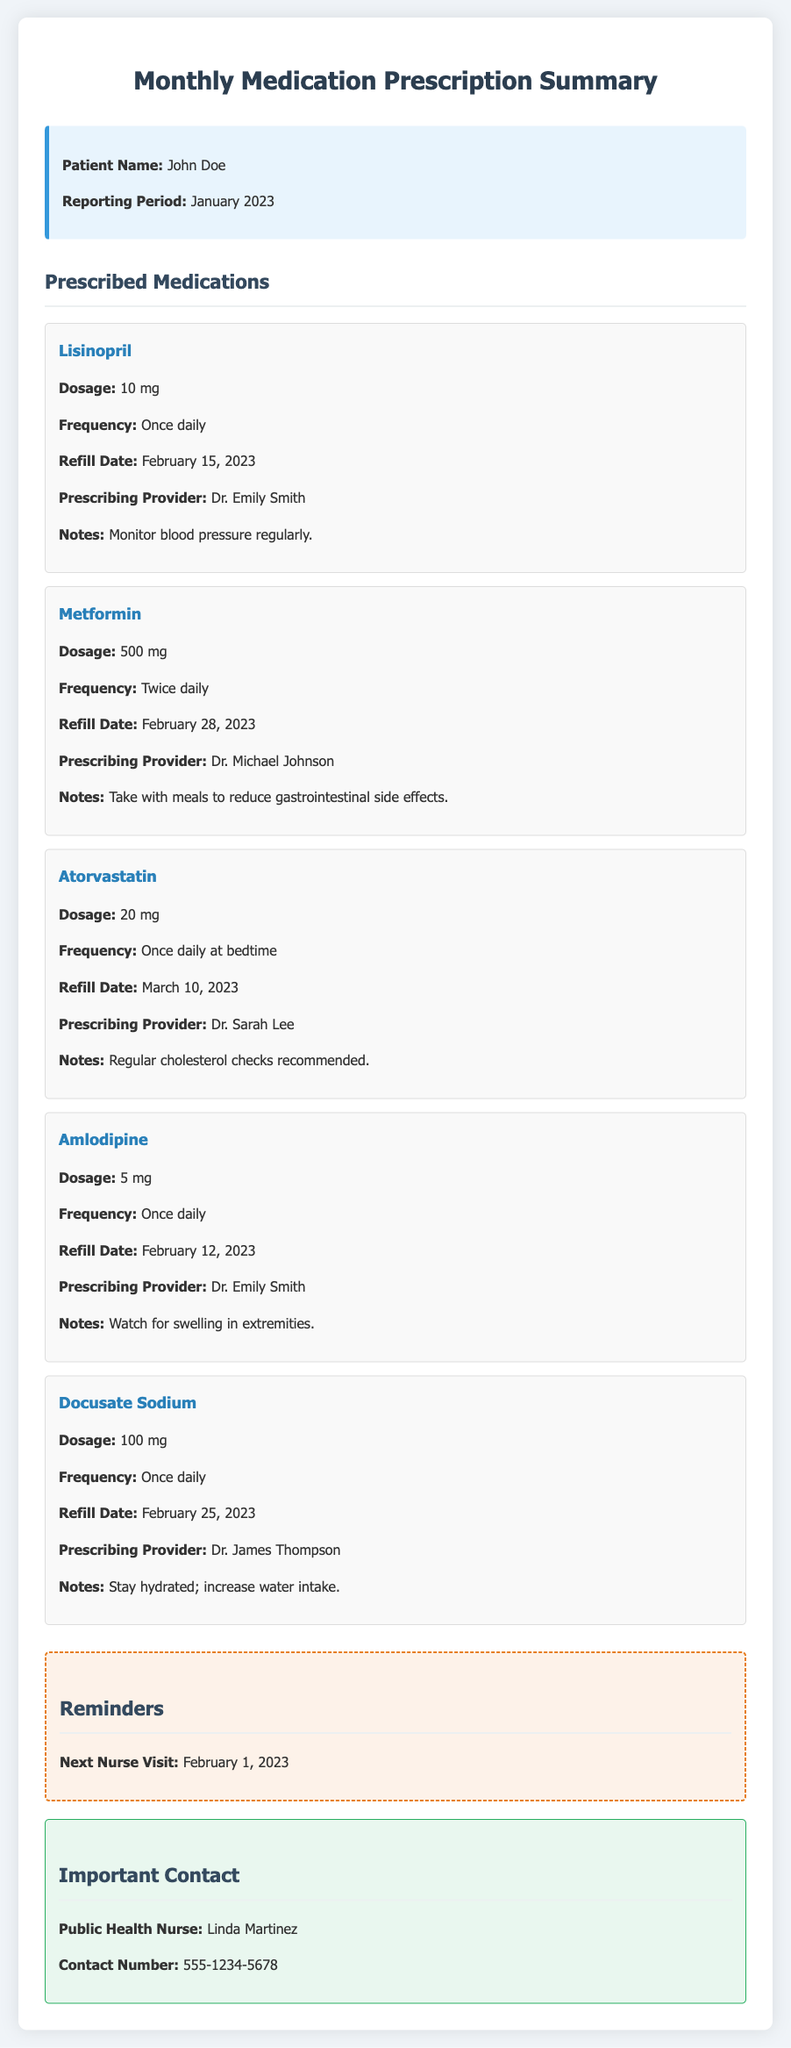What is the patient's name? The patient's name is provided at the beginning of the document under patient info.
Answer: John Doe What is the dosage of Metformin? The dosage for Metformin is mentioned in the medication details section.
Answer: 500 mg When is the refill date for Lisinopril? The refill date for Lisinopril can be found in the medication details for this medication.
Answer: February 15, 2023 How often should Atorvastatin be taken? The frequency for taking Atorvastatin is indicated in the medication details section.
Answer: Once daily at bedtime Who is the prescribing provider for Amlodipine? The name of the prescribing provider is mentioned under the medication details for Amlodipine.
Answer: Dr. Emily Smith What is the next nurse visit date? The next nurse visit date is included in the reminders section of the document.
Answer: February 1, 2023 What are the notes for Docusate Sodium? The notes for Docusate Sodium provide specific instructions related to this medication.
Answer: Stay hydrated; increase water intake How many medications are listed in total? The total number of medications is indicated by counting the items in the medication list.
Answer: 5 What is the contact number for the public health nurse? The contact number is provided in the important contact section of the document.
Answer: 555-1234-5678 